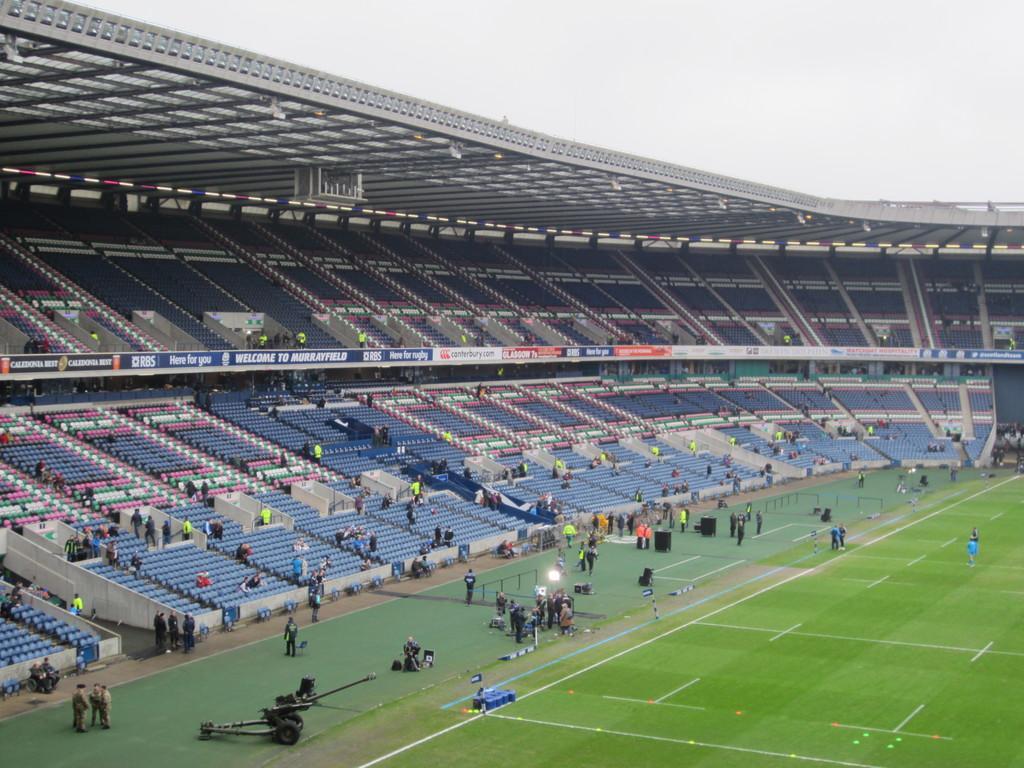Describe this image in one or two sentences. This is a picture of a stadium. In the center of the picture there are seats and few people are sitting. At the bottom it is ground covered with grass. In the foreground there are people, lights, speakers and other objects. Sky is cloudy. 